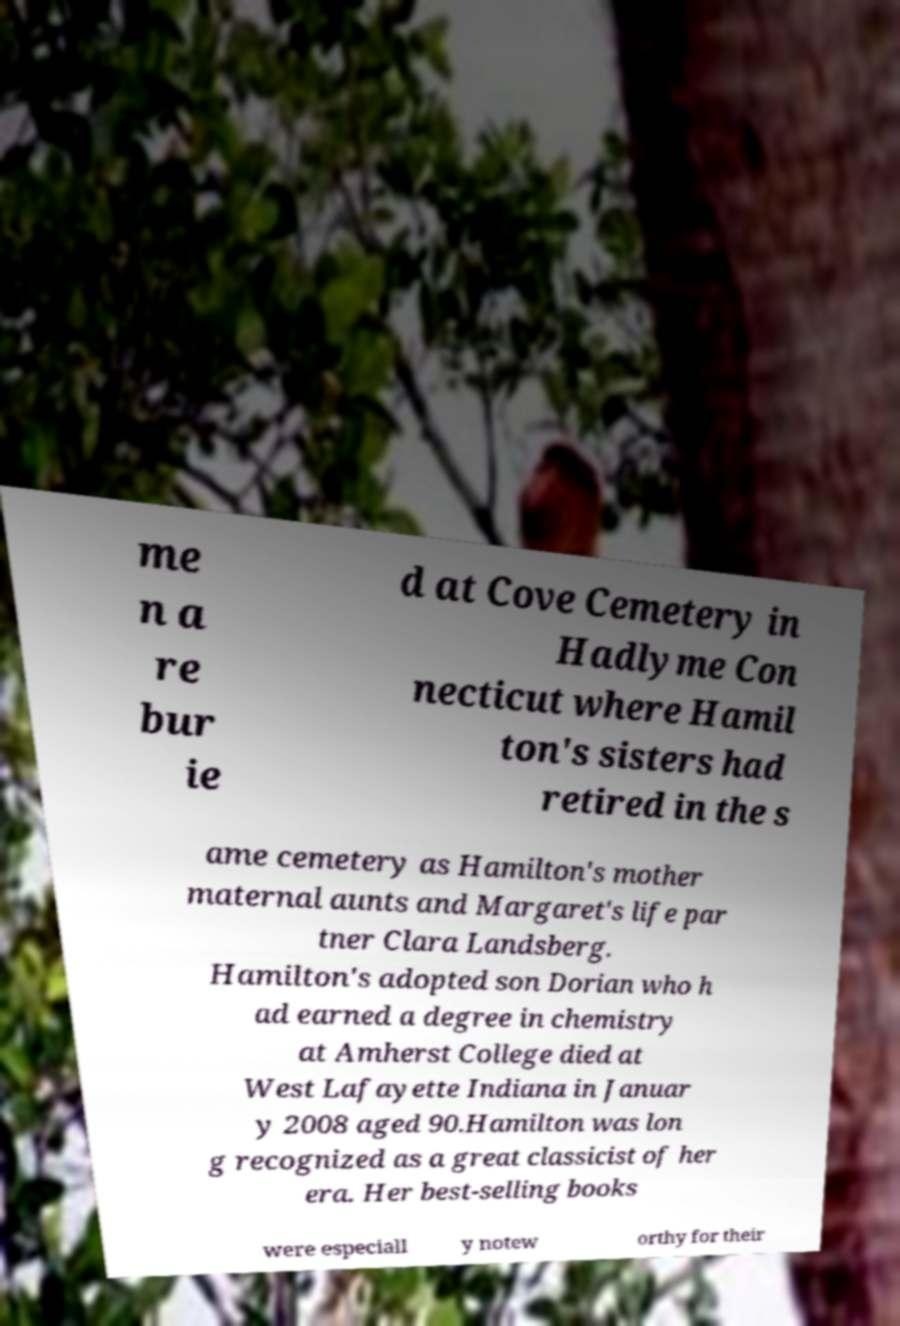What messages or text are displayed in this image? I need them in a readable, typed format. me n a re bur ie d at Cove Cemetery in Hadlyme Con necticut where Hamil ton's sisters had retired in the s ame cemetery as Hamilton's mother maternal aunts and Margaret's life par tner Clara Landsberg. Hamilton's adopted son Dorian who h ad earned a degree in chemistry at Amherst College died at West Lafayette Indiana in Januar y 2008 aged 90.Hamilton was lon g recognized as a great classicist of her era. Her best-selling books were especiall y notew orthy for their 